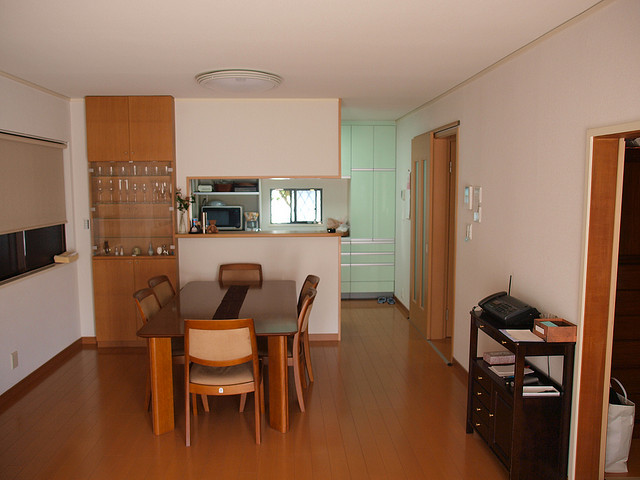<image>What will happen to the small room? I don't know what will happen to the small room. It could be used for dinner or meals. What will happen to the small room? I don't know what will happen to the small room. It can be used for dinner or people will eat there. 